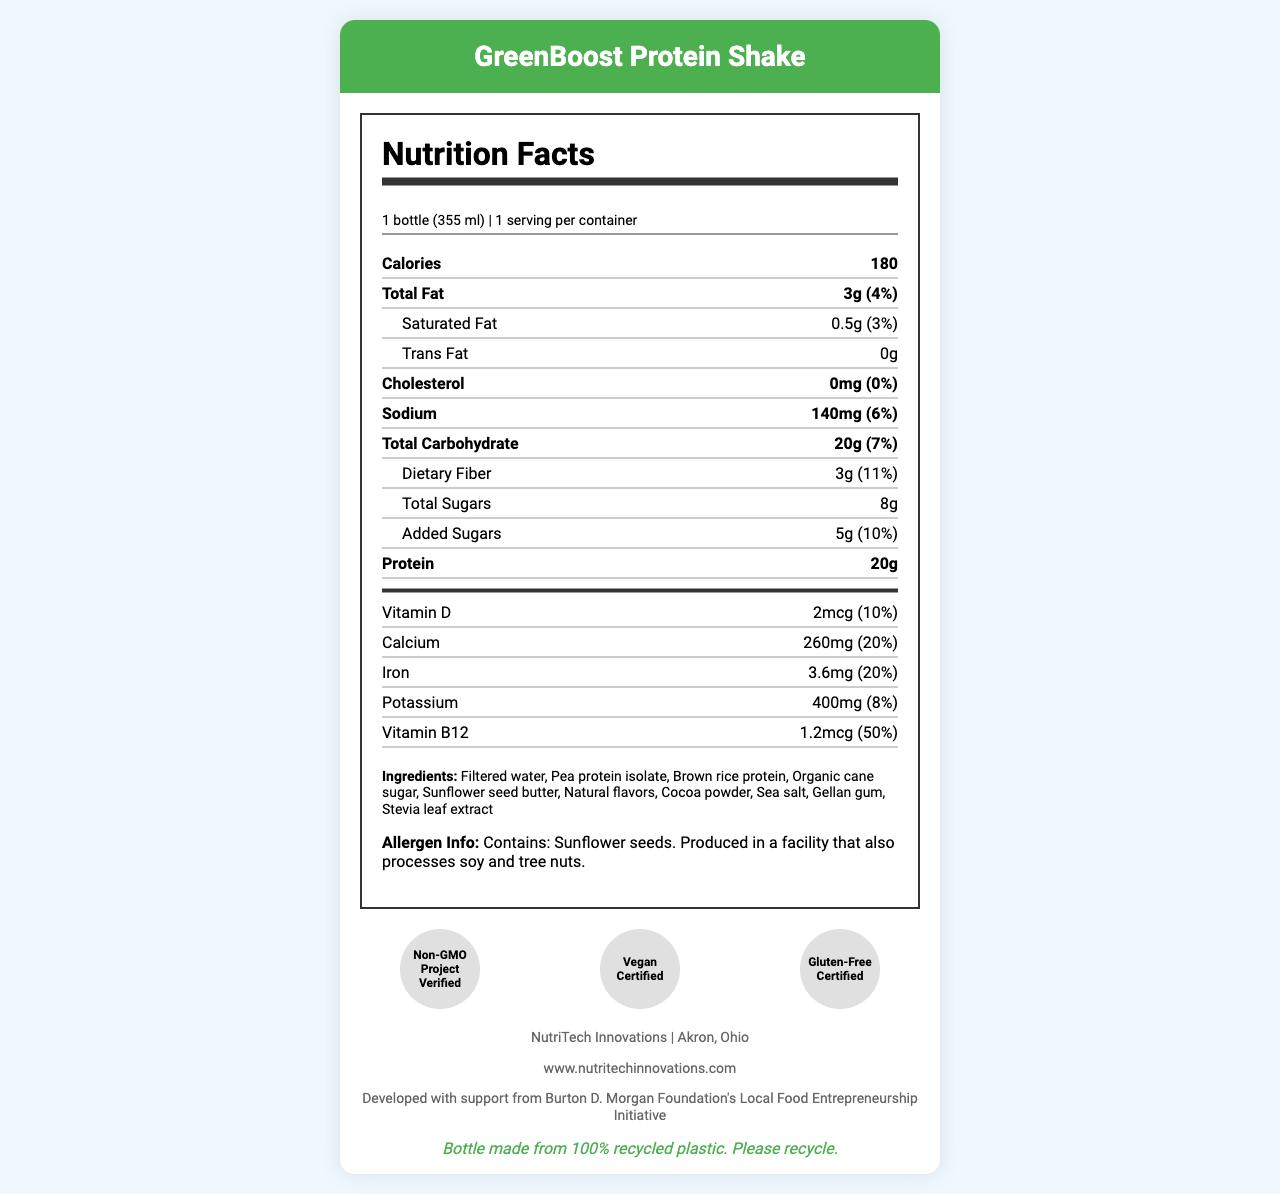what is the serving size? The serving size is mentioned at the top of the nutrition facts label as "1 bottle (355 ml)."
Answer: 1 bottle (355 ml) how many calories are in one serving of the GreenBoost Protein Shake? The number of calories per serving is listed next to "Calories" as 180.
Answer: 180 what percent of the daily value for calcium does this product provide? The daily value percentage for calcium is shown as 20%.
Answer: 20% is this product vegan certified? One of the certifications listed at the bottom of the document is "Vegan Certified."
Answer: Yes how much protein does the GreenBoost Protein Shake contain per serving? The amount of protein per serving is mentioned as 20g.
Answer: 20g how much total fat is in the GreenBoost Protein Shake? A. 2g B. 3g C. 4g D. 5g The total fat is listed as 3g.
Answer: B what is the daily value percentage for dietary fiber? A. 7% B. 10% C. 11% D. 15% The daily value percentage for dietary fiber is shown as 11%.
Answer: C does the product contain any trans fat? The trans fat content is listed as 0g.
Answer: No how much vitamin B12 is in the GreenBoost Protein Shake? The amount of vitamin B12 is listed as 1.2mcg.
Answer: 1.2mcg does the GreenBoost Protein Shake contain any nuts? The allergen information states that the product is produced in a facility that processes soy and tree nuts, but it doesn't specify if the shake contains nuts.
Answer: Not enough information what are the main ingredients in the GreenBoost Protein Shake? The list of ingredients is provided in the document.
Answer: Filtered water, Pea protein isolate, Brown rice protein, Organic cane sugar, Sunflower seed butter, Natural flavors, Cocoa powder, Sea salt, Gellan gum, Stevia leaf extract how much sodium does the product contain? The amount of sodium is listed as 140mg.
Answer: 140mg summarize the main nutritional facts and other relevant information about the GreenBoost Protein Shake. This summary of the document includes the core nutritional information, certifications, and sustainability details while highlighting the company's information.
Answer: The GreenBoost Protein Shake, produced by NutriTech Innovations in Akron, Ohio, contains 180 calories per 355 ml bottle and provides key nutrients such as 20g protein, 3g total fat, 8g total sugars, and 20g total carbohydrates. It also offers essential vitamins and minerals, including 20% daily value of calcium and iron, and 50% daily value of vitamin B12. It is certified vegan, non-GMO, and gluten-free, and the bottle is made from 100% recycled plastic. how many grams of added sugars are in the GreenBoost Protein Shake? The added sugars are listed as 5g.
Answer: 5g who is the producer of the GreenBoost Protein Shake? The company information states that NutriTech Innovations is the producer.
Answer: NutriTech Innovations where is NutriTech Innovations located? The company is located in Akron, Ohio, as mentioned in the company information section.
Answer: Akron, Ohio 